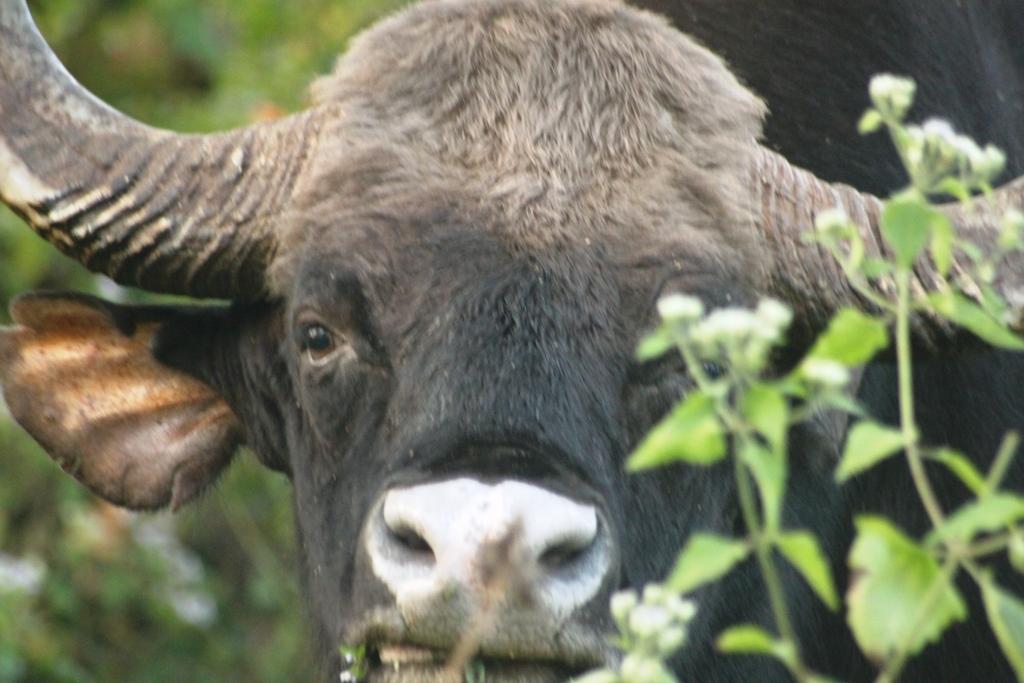Can you describe this image briefly? In the center of the image we can see a buffalo. In the background of the image we can see the plants. 